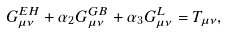Convert formula to latex. <formula><loc_0><loc_0><loc_500><loc_500>G _ { \mu \nu } ^ { E H } + \alpha _ { 2 } G _ { \mu \nu } ^ { G B } + \alpha _ { 3 } G _ { \mu \nu } ^ { L } = T _ { \mu \nu } ,</formula> 